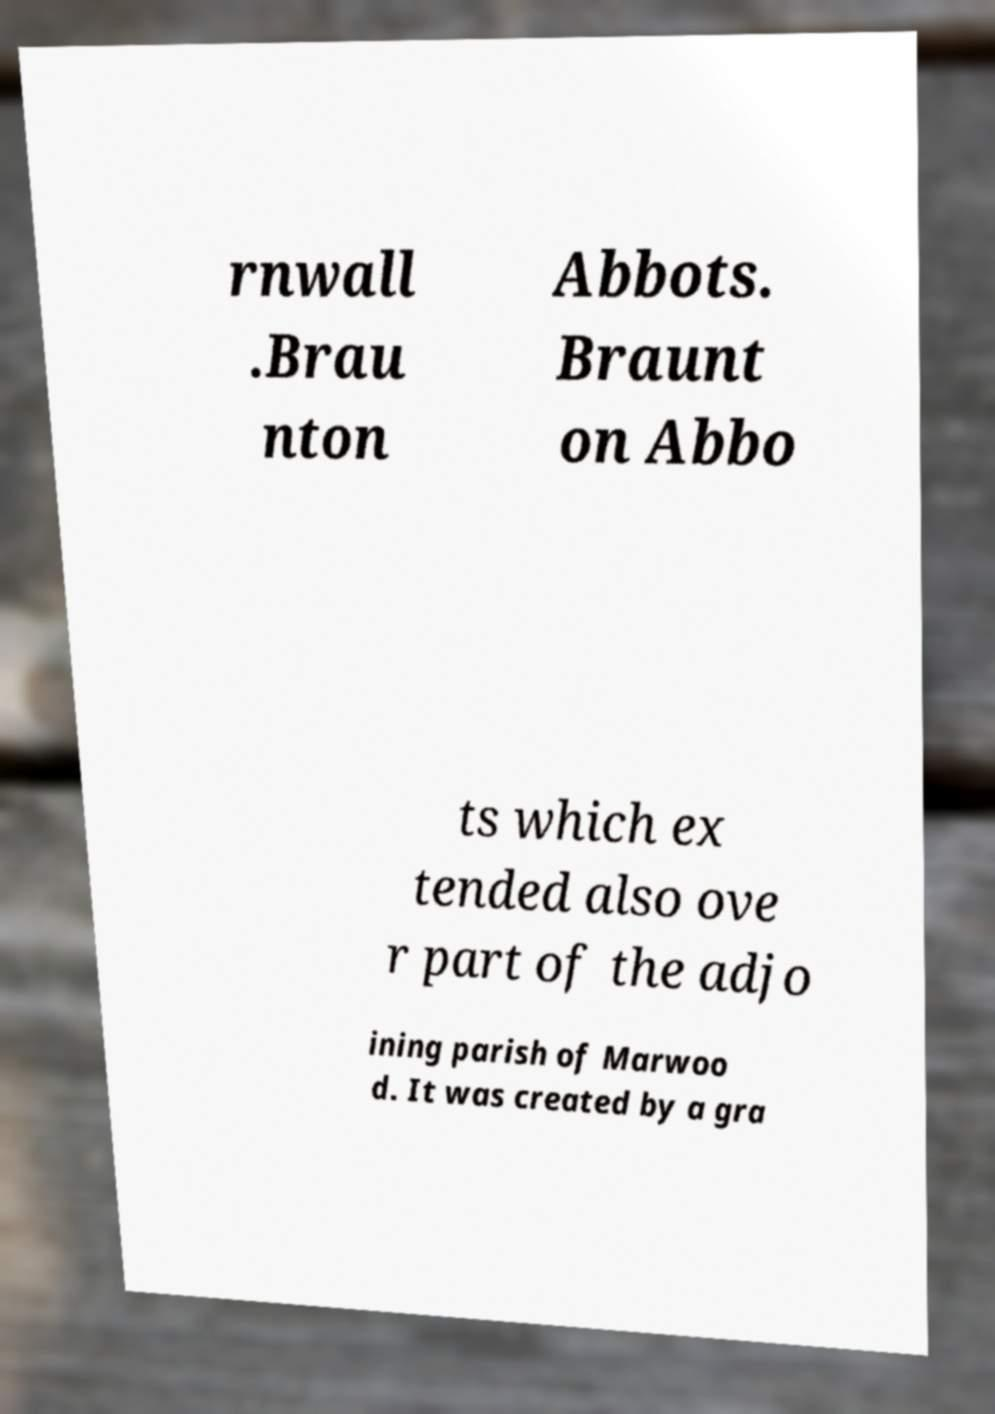I need the written content from this picture converted into text. Can you do that? rnwall .Brau nton Abbots. Braunt on Abbo ts which ex tended also ove r part of the adjo ining parish of Marwoo d. It was created by a gra 